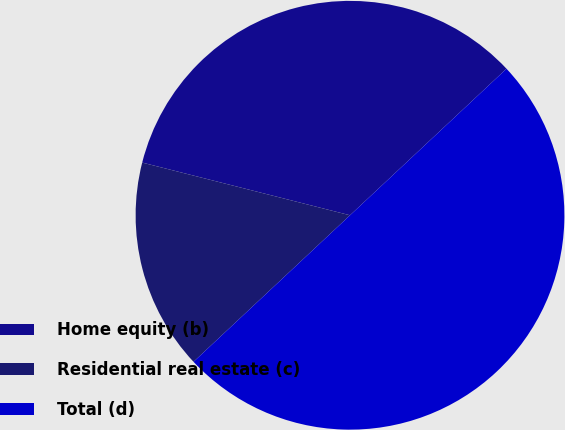Convert chart. <chart><loc_0><loc_0><loc_500><loc_500><pie_chart><fcel>Home equity (b)<fcel>Residential real estate (c)<fcel>Total (d)<nl><fcel>34.07%<fcel>15.93%<fcel>50.0%<nl></chart> 